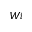Convert formula to latex. <formula><loc_0><loc_0><loc_500><loc_500>W i</formula> 